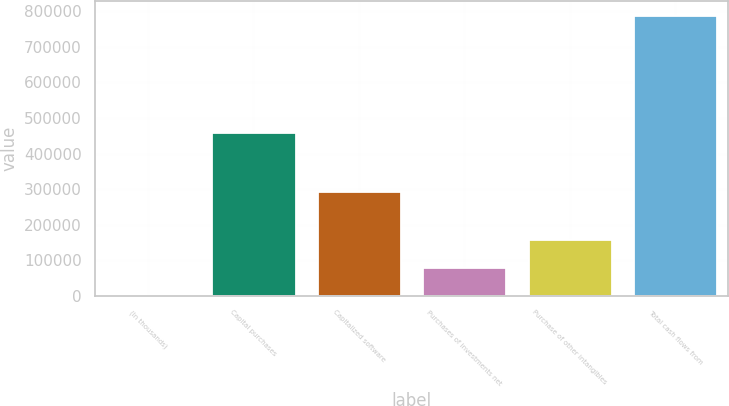<chart> <loc_0><loc_0><loc_500><loc_500><bar_chart><fcel>(In thousands)<fcel>Capital purchases<fcel>Capitalized software<fcel>Purchases of investments net<fcel>Purchase of other intangibles<fcel>Total cash flows from<nl><fcel>2016<fcel>459427<fcel>293696<fcel>80791.8<fcel>159568<fcel>789774<nl></chart> 